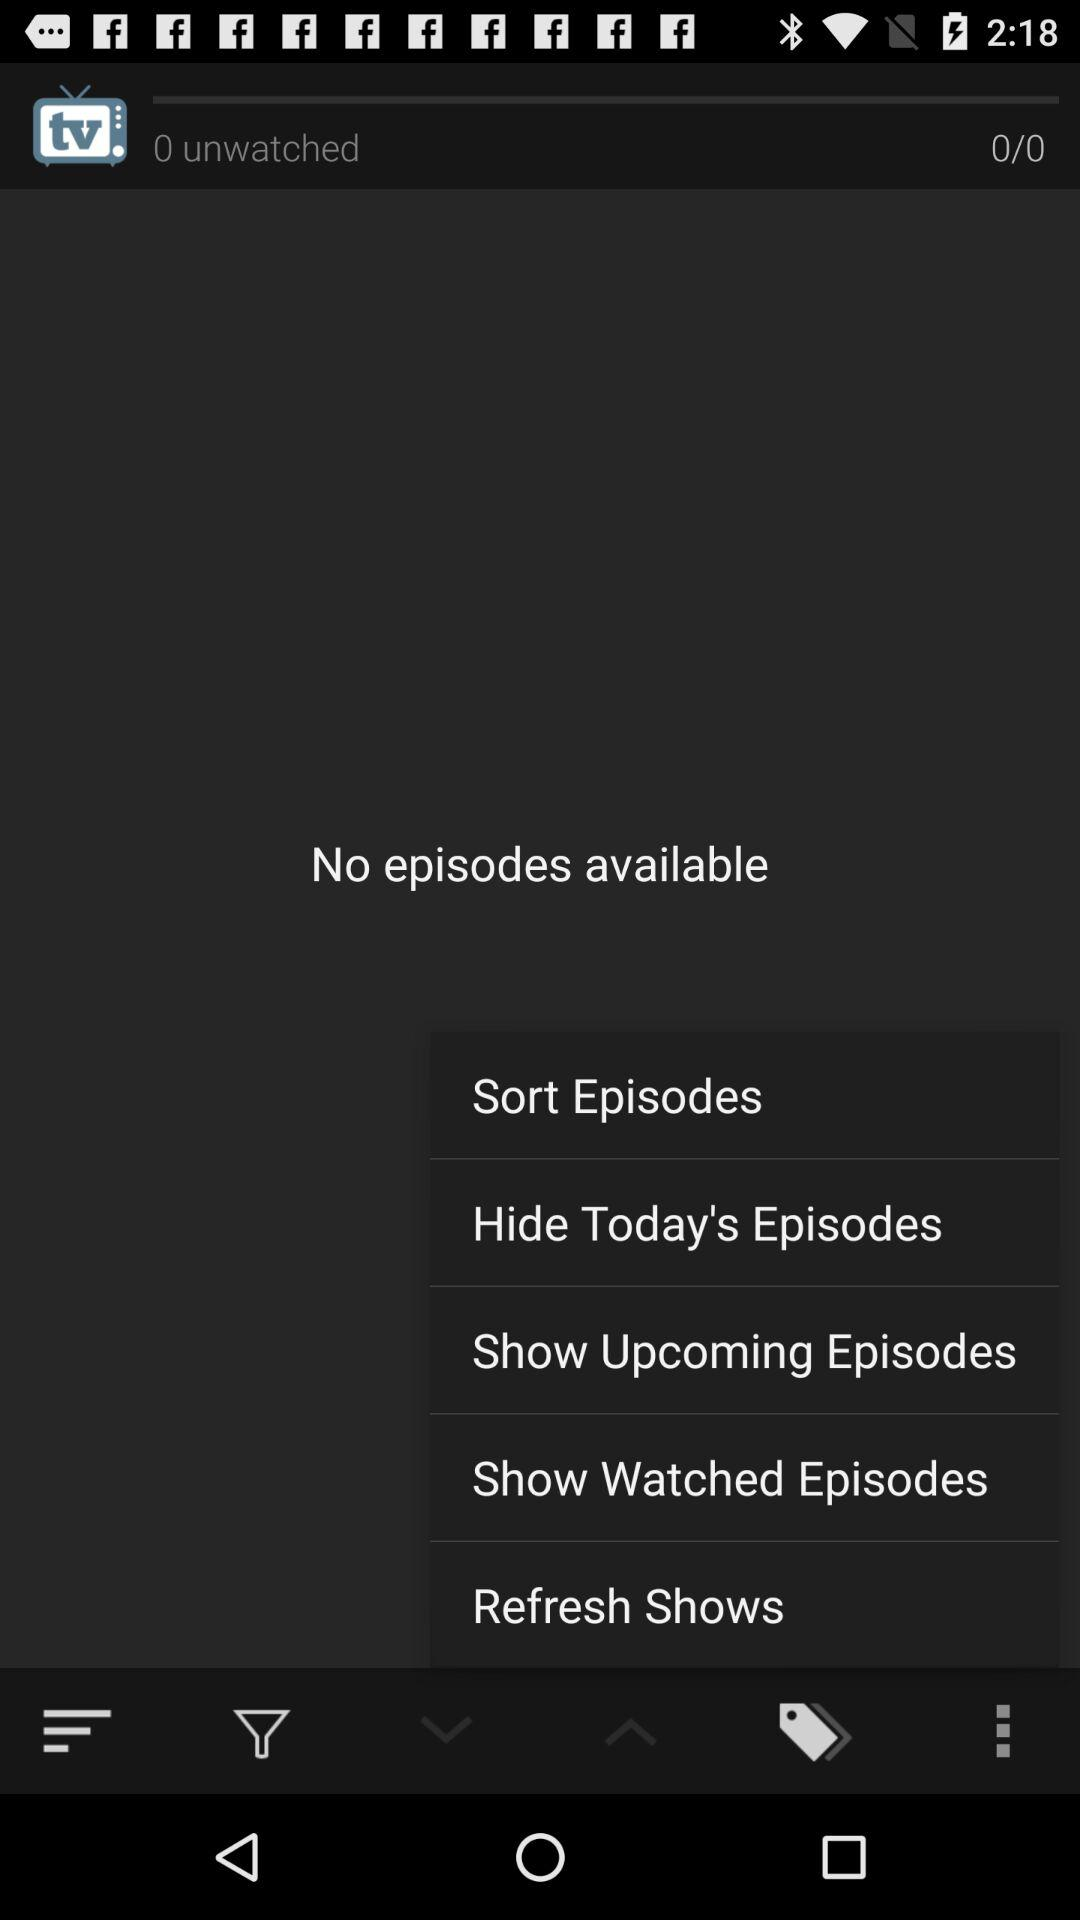What is the number of unwatched episodes? The number of unwatched episodes is 0. 